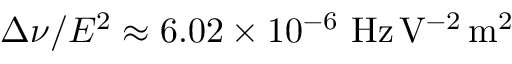<formula> <loc_0><loc_0><loc_500><loc_500>\Delta \nu / E ^ { 2 } \approx 6 . 0 2 \times 1 0 ^ { - 6 } \ H z \, V ^ { - 2 } \, m ^ { 2 }</formula> 